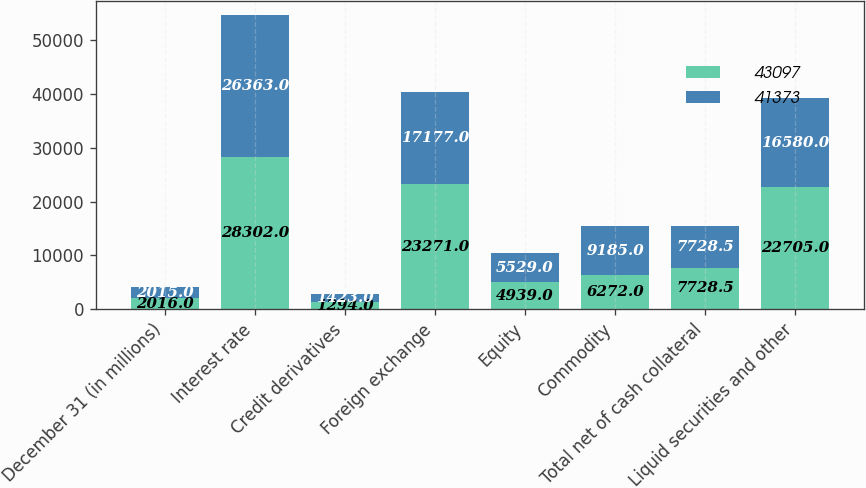Convert chart to OTSL. <chart><loc_0><loc_0><loc_500><loc_500><stacked_bar_chart><ecel><fcel>December 31 (in millions)<fcel>Interest rate<fcel>Credit derivatives<fcel>Foreign exchange<fcel>Equity<fcel>Commodity<fcel>Total net of cash collateral<fcel>Liquid securities and other<nl><fcel>43097<fcel>2016<fcel>28302<fcel>1294<fcel>23271<fcel>4939<fcel>6272<fcel>7728.5<fcel>22705<nl><fcel>41373<fcel>2015<fcel>26363<fcel>1423<fcel>17177<fcel>5529<fcel>9185<fcel>7728.5<fcel>16580<nl></chart> 